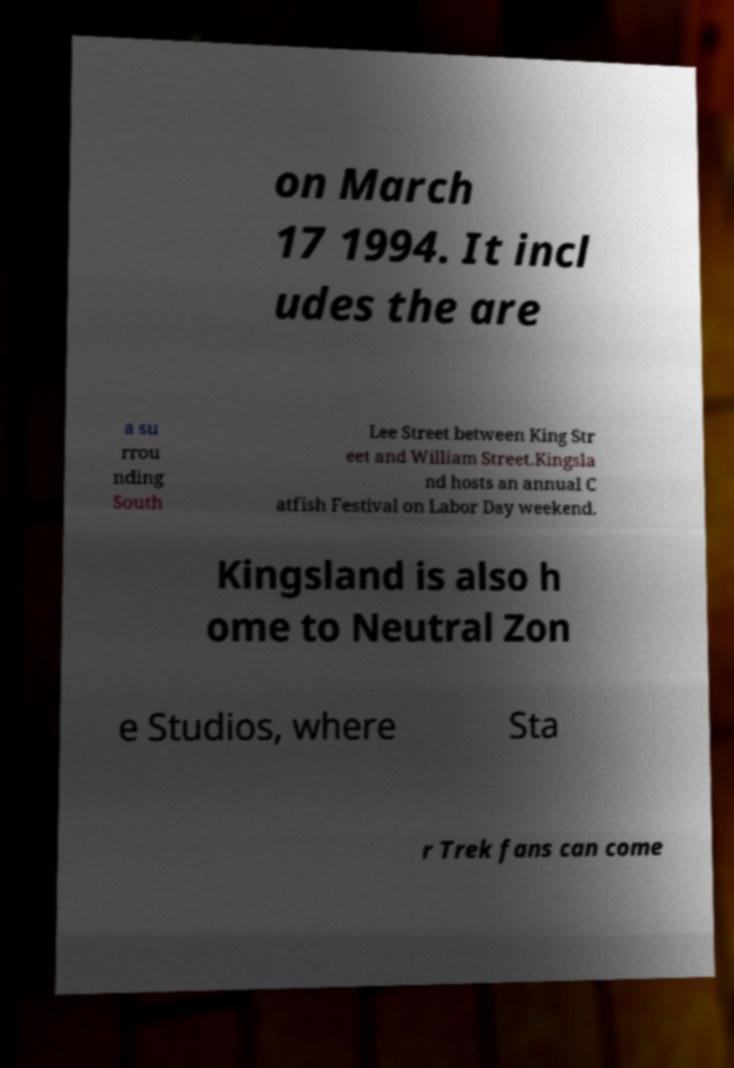For documentation purposes, I need the text within this image transcribed. Could you provide that? on March 17 1994. It incl udes the are a su rrou nding South Lee Street between King Str eet and William Street.Kingsla nd hosts an annual C atfish Festival on Labor Day weekend. Kingsland is also h ome to Neutral Zon e Studios, where Sta r Trek fans can come 